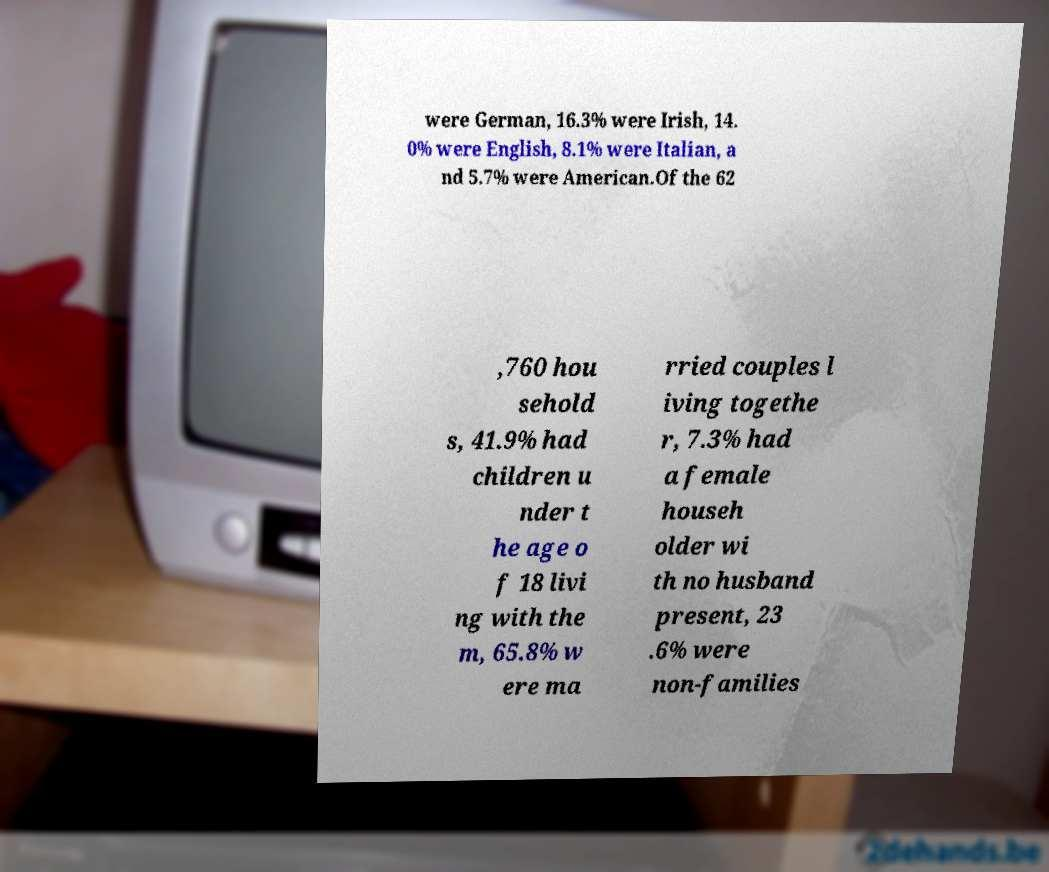Can you read and provide the text displayed in the image?This photo seems to have some interesting text. Can you extract and type it out for me? were German, 16.3% were Irish, 14. 0% were English, 8.1% were Italian, a nd 5.7% were American.Of the 62 ,760 hou sehold s, 41.9% had children u nder t he age o f 18 livi ng with the m, 65.8% w ere ma rried couples l iving togethe r, 7.3% had a female househ older wi th no husband present, 23 .6% were non-families 